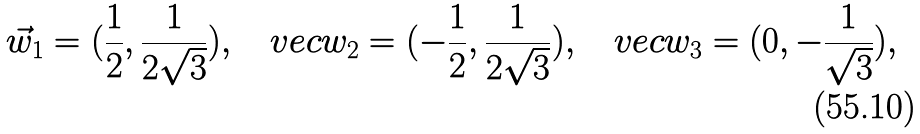<formula> <loc_0><loc_0><loc_500><loc_500>\vec { w } _ { 1 } = ( \frac { 1 } { 2 } , \frac { 1 } { 2 \sqrt { 3 } } ) , \ \ \ v e c { w } _ { 2 } = ( - \frac { 1 } { 2 } , \frac { 1 } { 2 \sqrt { 3 } } ) , \ \ \ v e c { w } _ { 3 } = ( 0 , - \frac { 1 } { \sqrt { 3 } } ) , \ \</formula> 